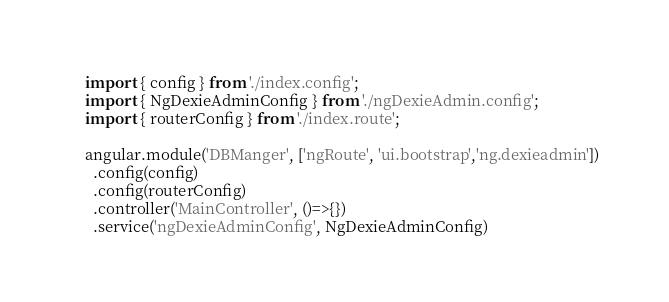<code> <loc_0><loc_0><loc_500><loc_500><_JavaScript_>import { config } from './index.config';
import { NgDexieAdminConfig } from './ngDexieAdmin.config';
import { routerConfig } from './index.route';

angular.module('DBManger', ['ngRoute', 'ui.bootstrap','ng.dexieadmin'])
  .config(config)
  .config(routerConfig)
  .controller('MainController', ()=>{})
  .service('ngDexieAdminConfig', NgDexieAdminConfig)
</code> 